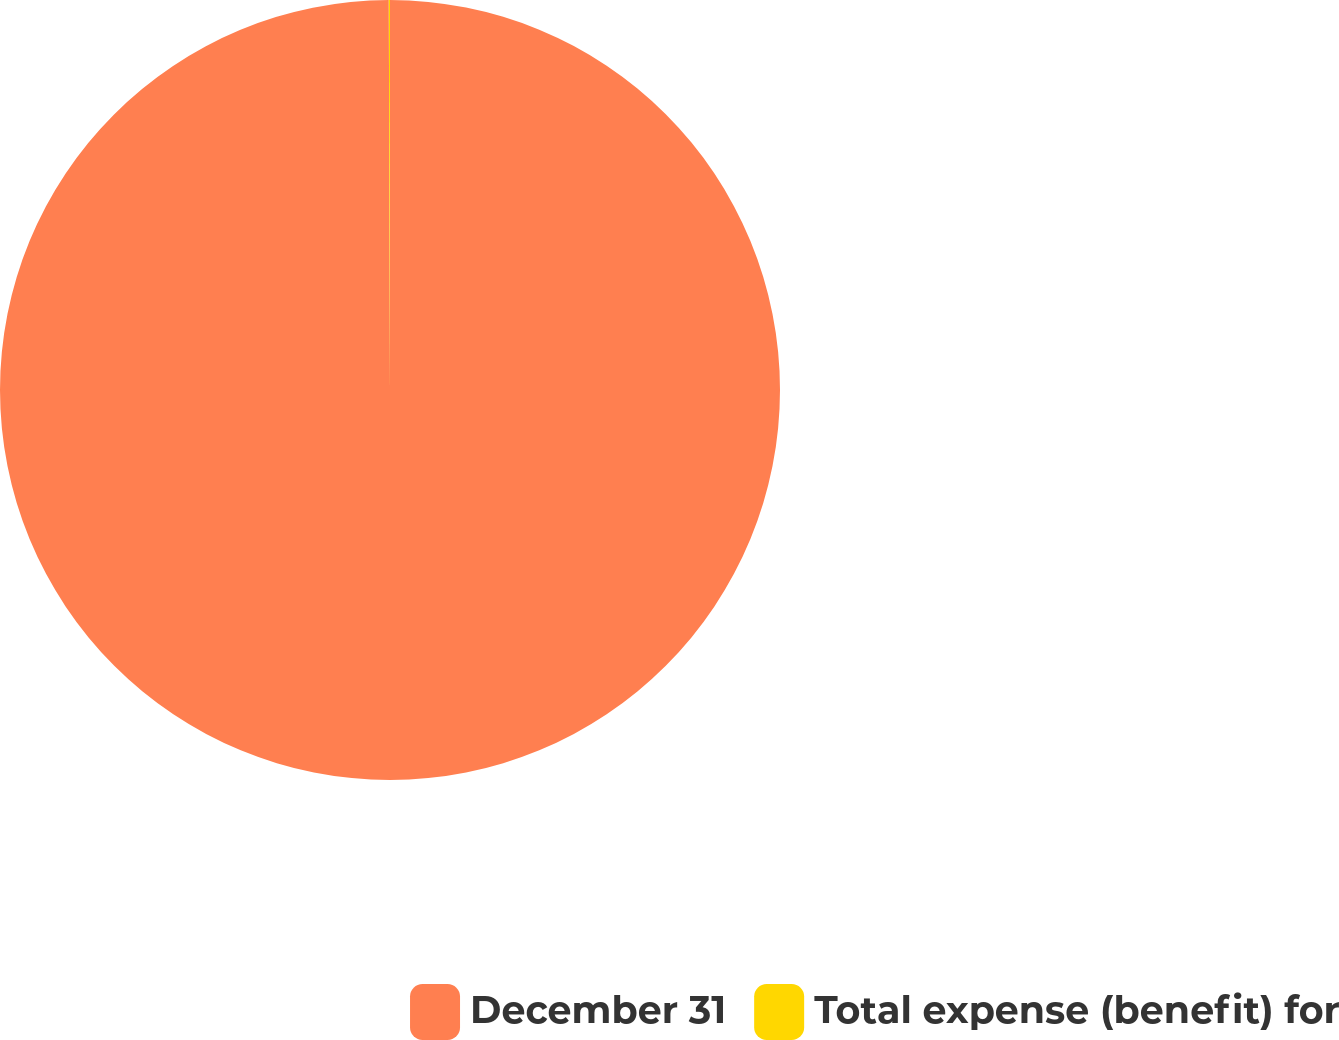<chart> <loc_0><loc_0><loc_500><loc_500><pie_chart><fcel>December 31<fcel>Total expense (benefit) for<nl><fcel>99.95%<fcel>0.05%<nl></chart> 